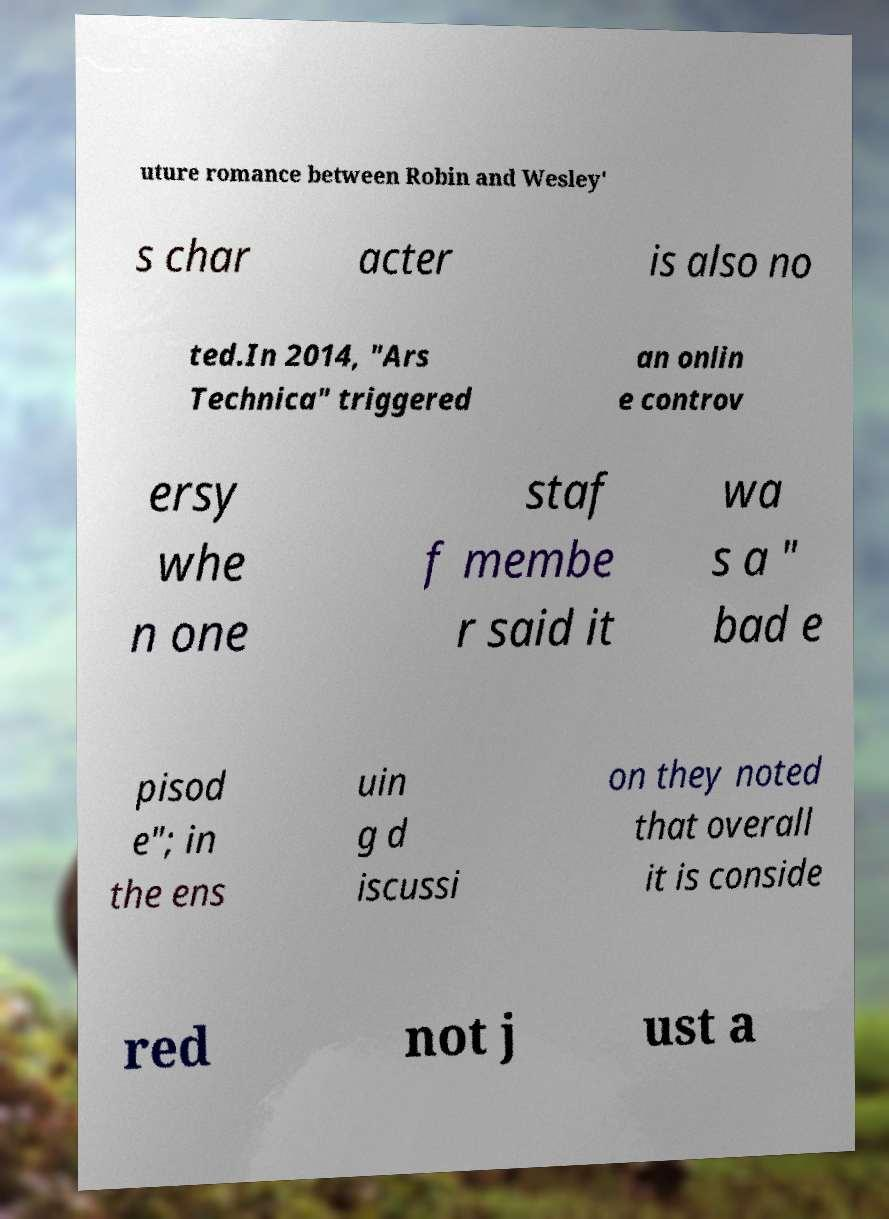Please read and relay the text visible in this image. What does it say? uture romance between Robin and Wesley' s char acter is also no ted.In 2014, "Ars Technica" triggered an onlin e controv ersy whe n one staf f membe r said it wa s a " bad e pisod e"; in the ens uin g d iscussi on they noted that overall it is conside red not j ust a 